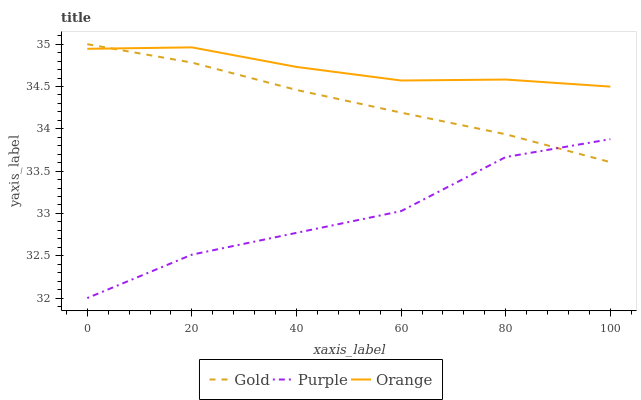Does Purple have the minimum area under the curve?
Answer yes or no. Yes. Does Orange have the maximum area under the curve?
Answer yes or no. Yes. Does Gold have the minimum area under the curve?
Answer yes or no. No. Does Gold have the maximum area under the curve?
Answer yes or no. No. Is Gold the smoothest?
Answer yes or no. Yes. Is Purple the roughest?
Answer yes or no. Yes. Is Orange the smoothest?
Answer yes or no. No. Is Orange the roughest?
Answer yes or no. No. Does Purple have the lowest value?
Answer yes or no. Yes. Does Gold have the lowest value?
Answer yes or no. No. Does Gold have the highest value?
Answer yes or no. Yes. Does Orange have the highest value?
Answer yes or no. No. Is Purple less than Orange?
Answer yes or no. Yes. Is Orange greater than Purple?
Answer yes or no. Yes. Does Purple intersect Gold?
Answer yes or no. Yes. Is Purple less than Gold?
Answer yes or no. No. Is Purple greater than Gold?
Answer yes or no. No. Does Purple intersect Orange?
Answer yes or no. No. 